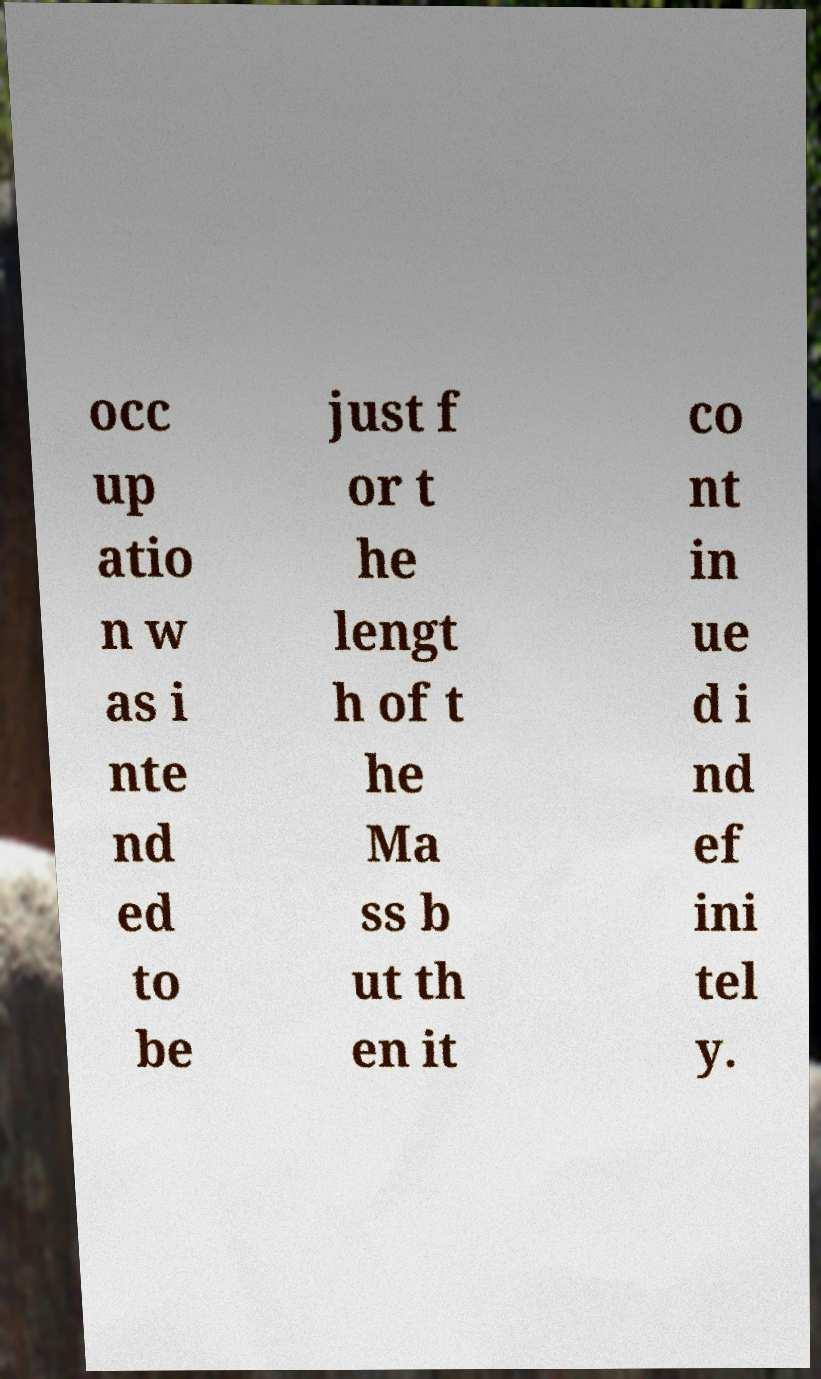There's text embedded in this image that I need extracted. Can you transcribe it verbatim? occ up atio n w as i nte nd ed to be just f or t he lengt h of t he Ma ss b ut th en it co nt in ue d i nd ef ini tel y. 